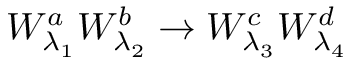Convert formula to latex. <formula><loc_0><loc_0><loc_500><loc_500>W _ { \lambda _ { 1 } } ^ { a } W _ { \lambda _ { 2 } } ^ { b } \to W _ { \lambda _ { 3 } } ^ { c } W _ { \lambda _ { 4 } } ^ { d }</formula> 